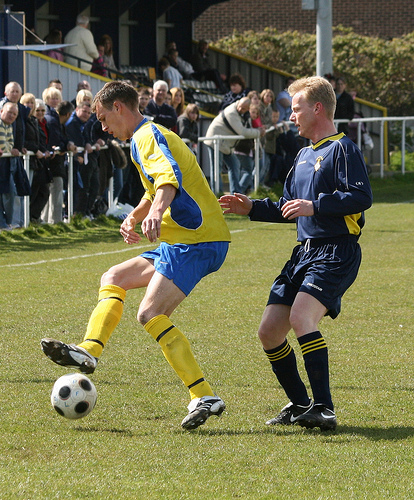<image>
Can you confirm if the boot is on the ball? No. The boot is not positioned on the ball. They may be near each other, but the boot is not supported by or resting on top of the ball. Is the ball under the boy? Yes. The ball is positioned underneath the boy, with the boy above it in the vertical space. 